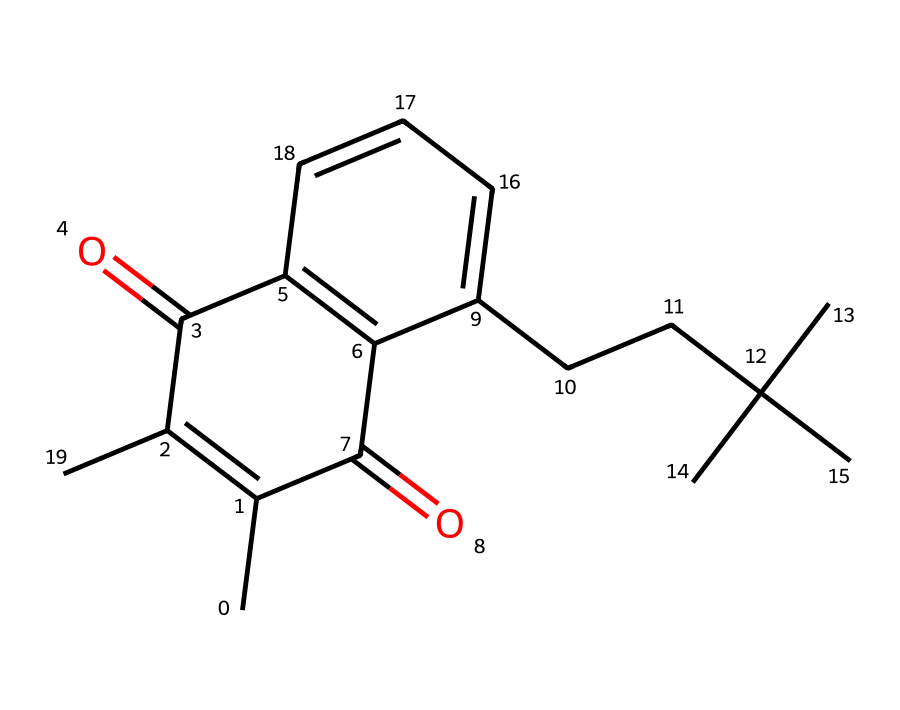What is the name of this vitamin? The SMILES structure corresponds to vitamin K, specifically vitamin K1 or phylloquinone, known for its role in blood coagulation.
Answer: vitamin K How many carbon atoms are in the structure? The structure contains 15 carbon atoms, which can be counted directly from the SMILES representation, noting each "C" indicates a carbon atom.
Answer: 15 What functional groups are present in the structure? The chemical structure contains a ketone group (C=O) and various alkene groups (C=C), identifiable by the double bonds in the SMILES.
Answer: ketone, alkene How many rings are present in the molecular structure? The structure features a naphthoquinone core, which indicates there are two interconnected rings present in the molecule.
Answer: 2 What is the primary role of vitamin K in the body? Vitamin K is primarily involved in blood clotting, activating proteins that help prevent excessive bleeding.
Answer: blood clotting How does the structure of vitamin K relate to its function? The presence of the quinone functionality allows vitamin K to undergo redox reactions, which are essential for the activation of clotting factors in the liver.
Answer: redox reactions Which molecule does vitamin K interact with to aid clotting? Vitamin K interacts with clotting factors such as prothrombin, which is necessary for the coagulation process in blood.
Answer: prothrombin 